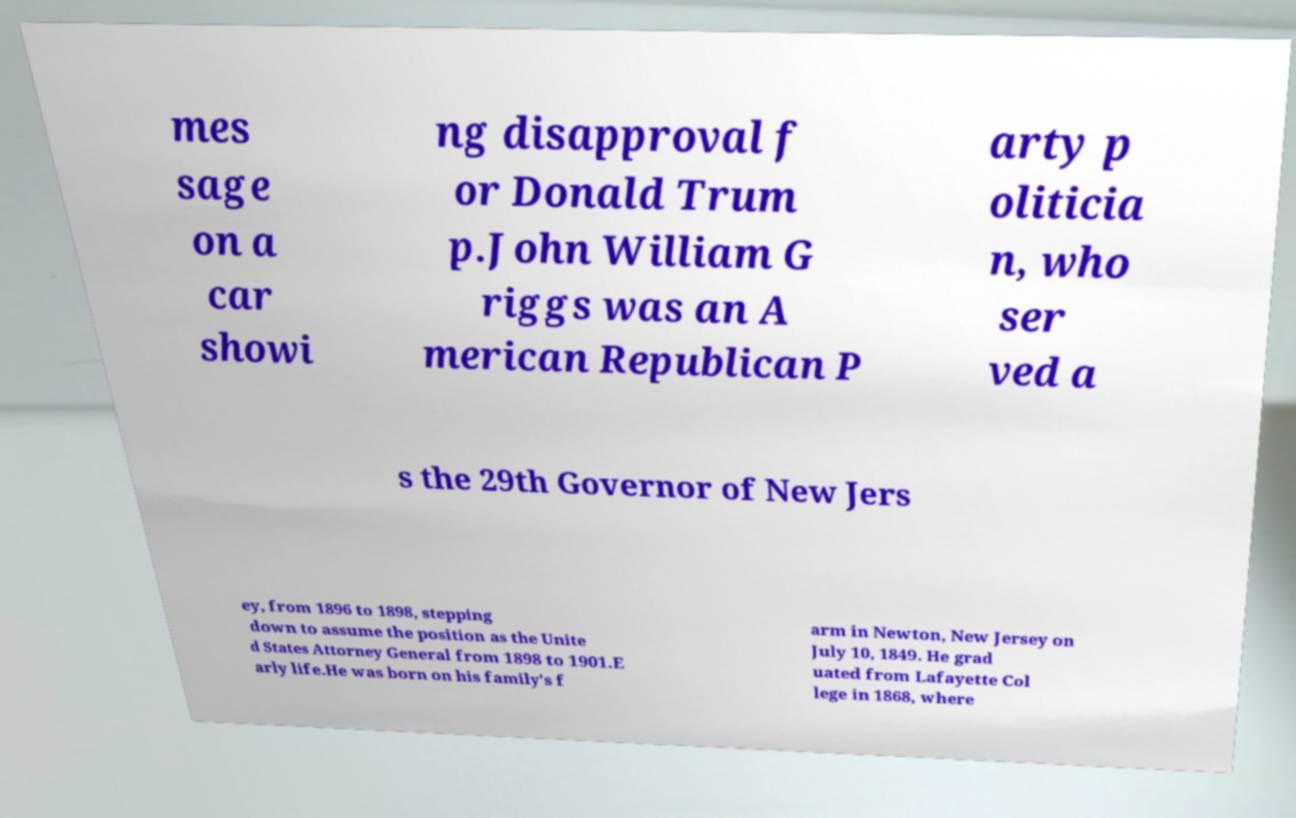For documentation purposes, I need the text within this image transcribed. Could you provide that? mes sage on a car showi ng disapproval f or Donald Trum p.John William G riggs was an A merican Republican P arty p oliticia n, who ser ved a s the 29th Governor of New Jers ey, from 1896 to 1898, stepping down to assume the position as the Unite d States Attorney General from 1898 to 1901.E arly life.He was born on his family's f arm in Newton, New Jersey on July 10, 1849. He grad uated from Lafayette Col lege in 1868, where 